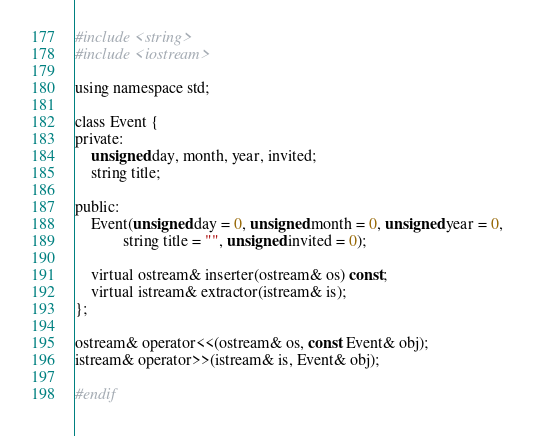<code> <loc_0><loc_0><loc_500><loc_500><_C_>#include <string>
#include <iostream>

using namespace std;

class Event {
private:
    unsigned day, month, year, invited;
    string title;
    
public:
    Event(unsigned day = 0, unsigned month = 0, unsigned year = 0, 
            string title = "", unsigned invited = 0);

    virtual ostream& inserter(ostream& os) const;
    virtual istream& extractor(istream& is);
};

ostream& operator<<(ostream& os, const Event& obj);
istream& operator>>(istream& is, Event& obj);

#endif

</code> 